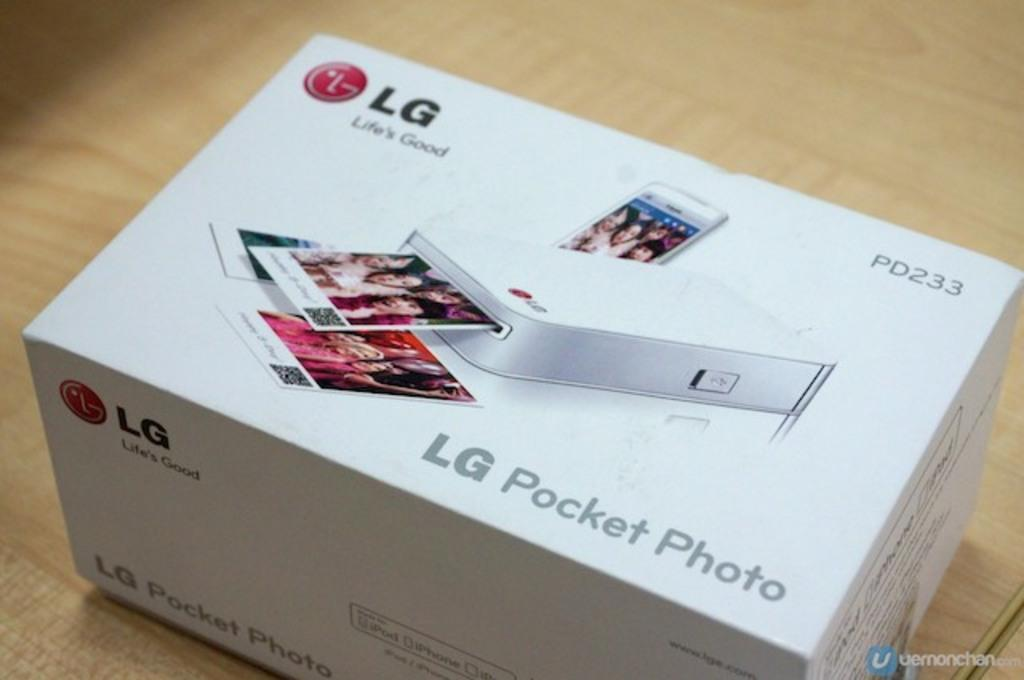<image>
Render a clear and concise summary of the photo. A box contains a an LG pocket photo printer. 